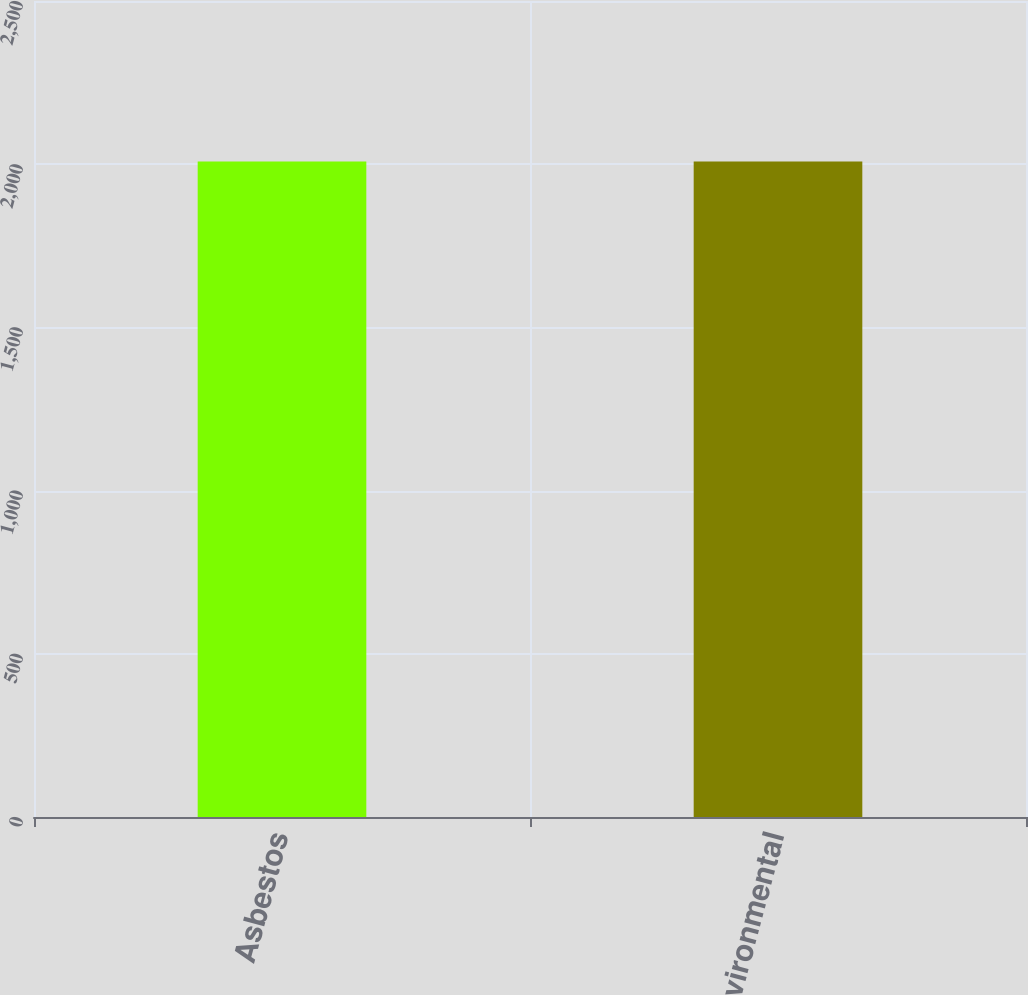Convert chart to OTSL. <chart><loc_0><loc_0><loc_500><loc_500><bar_chart><fcel>Asbestos<fcel>Environmental<nl><fcel>2008<fcel>2008.1<nl></chart> 